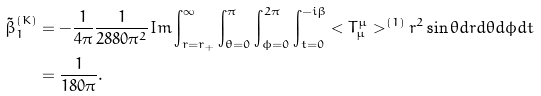<formula> <loc_0><loc_0><loc_500><loc_500>\tilde { \beta } _ { 1 } ^ { ( K ) } & = - \frac { 1 } { 4 \pi } \frac { 1 } { 2 8 8 0 \pi ^ { 2 } } { I m } \int _ { r = r _ { + } } ^ { \infty } \int _ { \theta = 0 } ^ { \pi } \int _ { \phi = 0 } ^ { 2 \pi } \int _ { t = 0 } ^ { - i \beta } { < T ^ { \mu } _ { \mu } > ^ { ( 1 ) } r ^ { 2 } \sin \theta d r d \theta d \phi d t } \\ & = \frac { 1 } { 1 8 0 \pi } .</formula> 